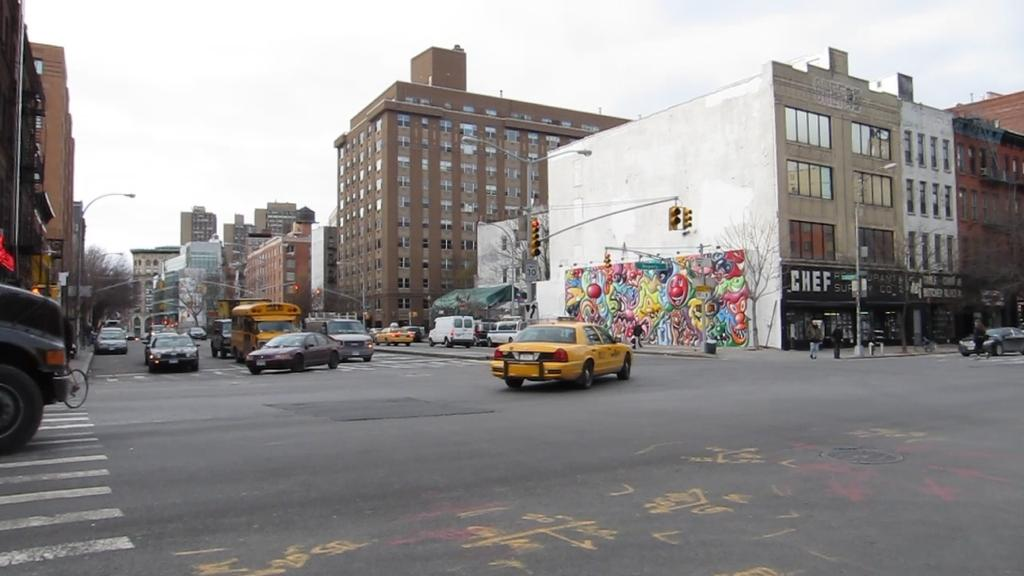<image>
Offer a succinct explanation of the picture presented. A yellow cab turns at an intersection, with a store with "chef" written on the sign. 